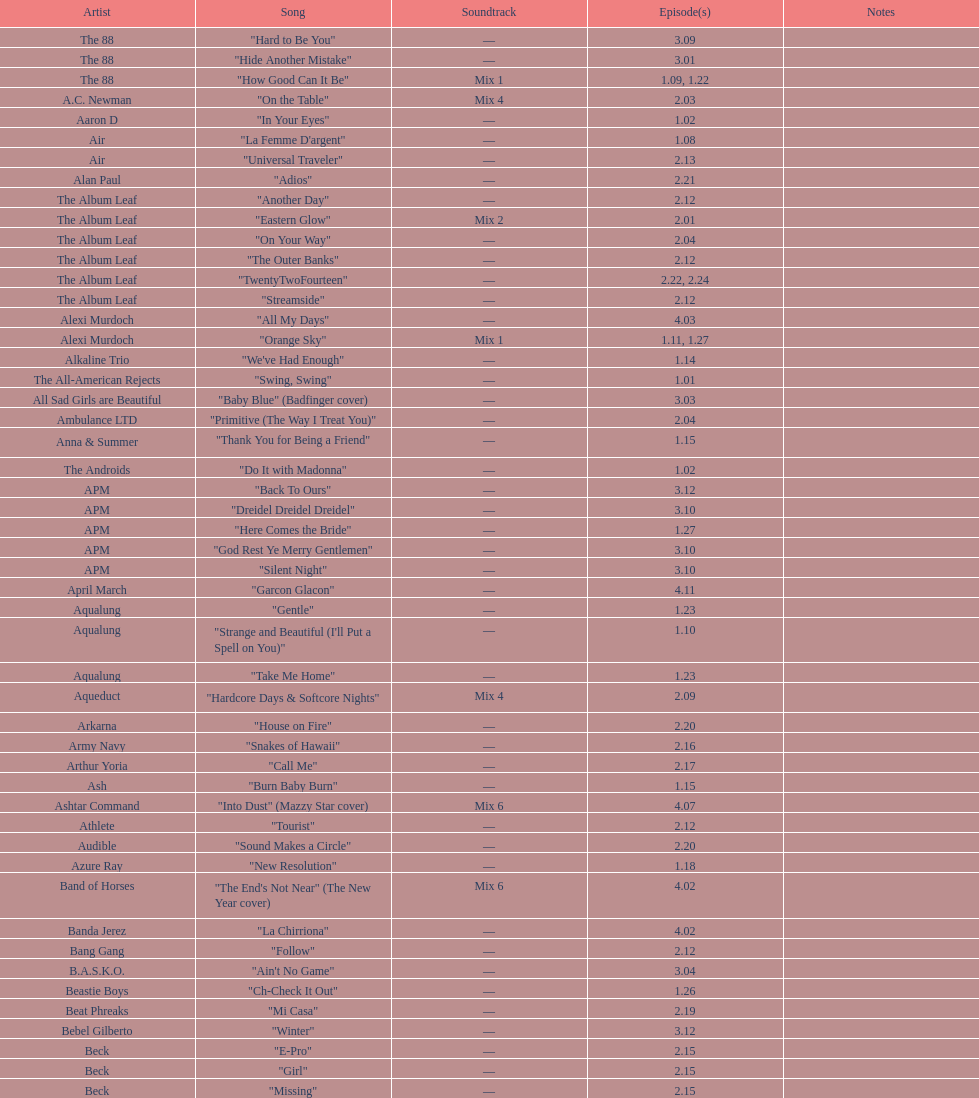The artist ash only had one song that appeared in the o.c. what is the name of that song? "Burn Baby Burn". 